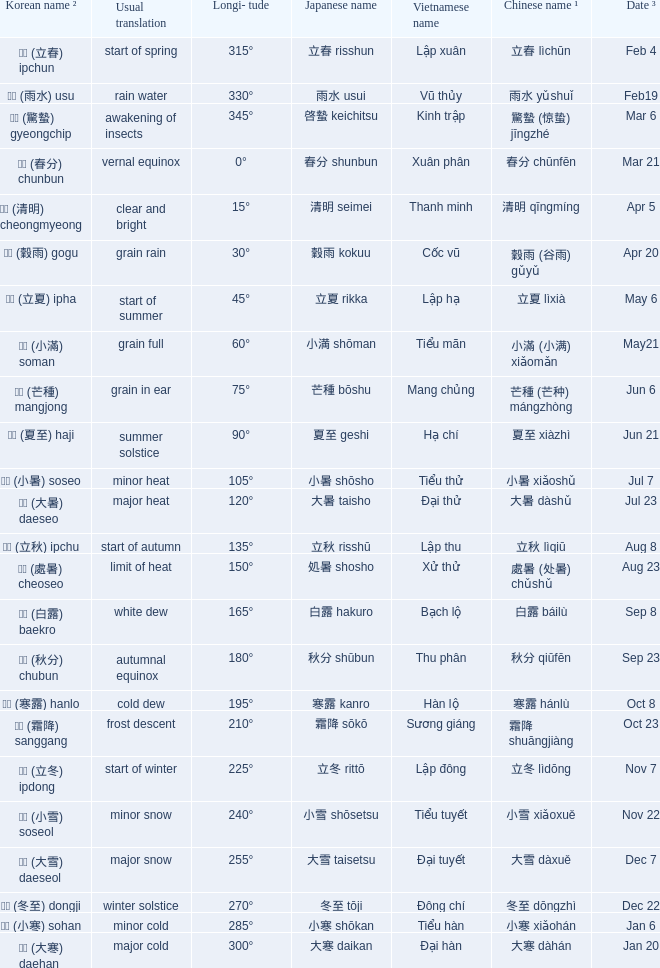WHich Usual translation is on sep 23? Autumnal equinox. 